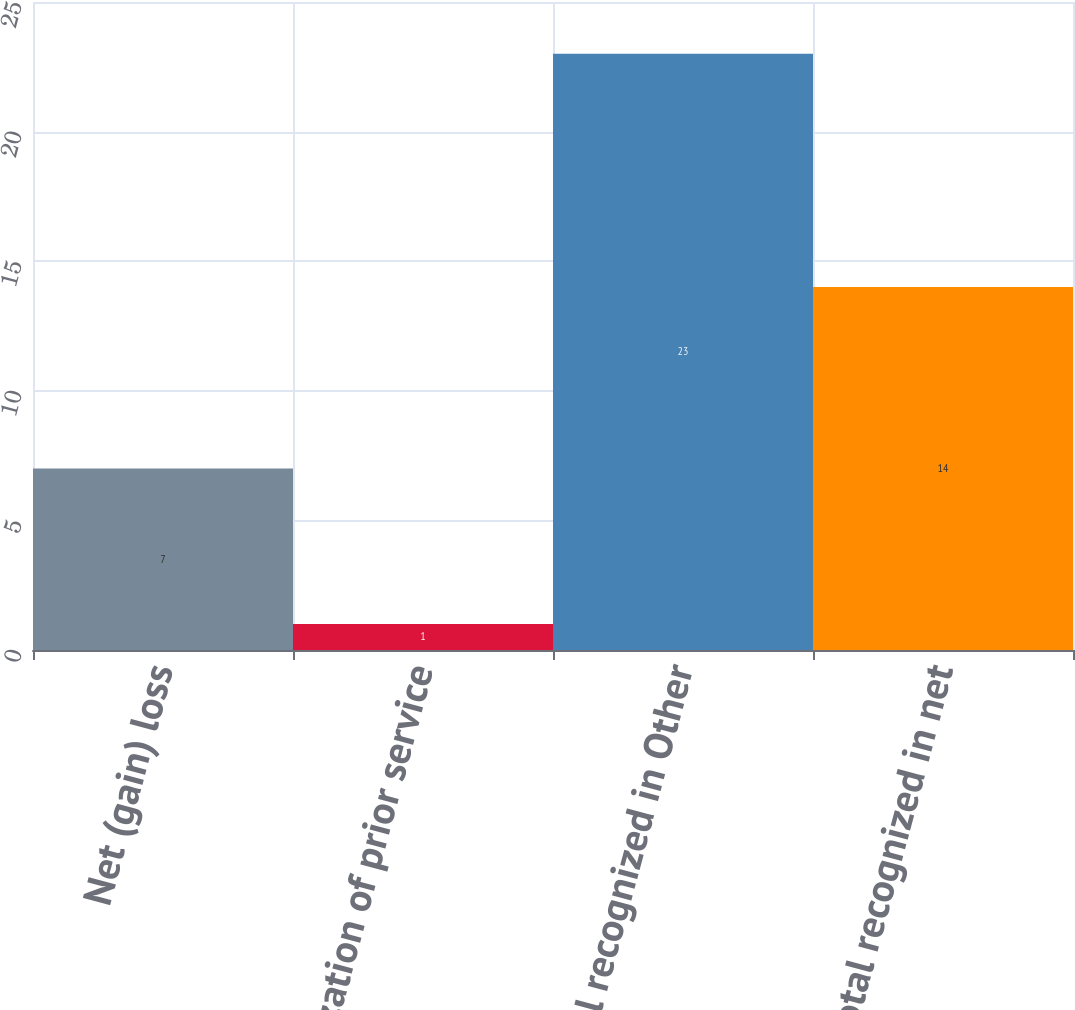Convert chart. <chart><loc_0><loc_0><loc_500><loc_500><bar_chart><fcel>Net (gain) loss<fcel>Amortization of prior service<fcel>Total recognized in Other<fcel>Total recognized in net<nl><fcel>7<fcel>1<fcel>23<fcel>14<nl></chart> 